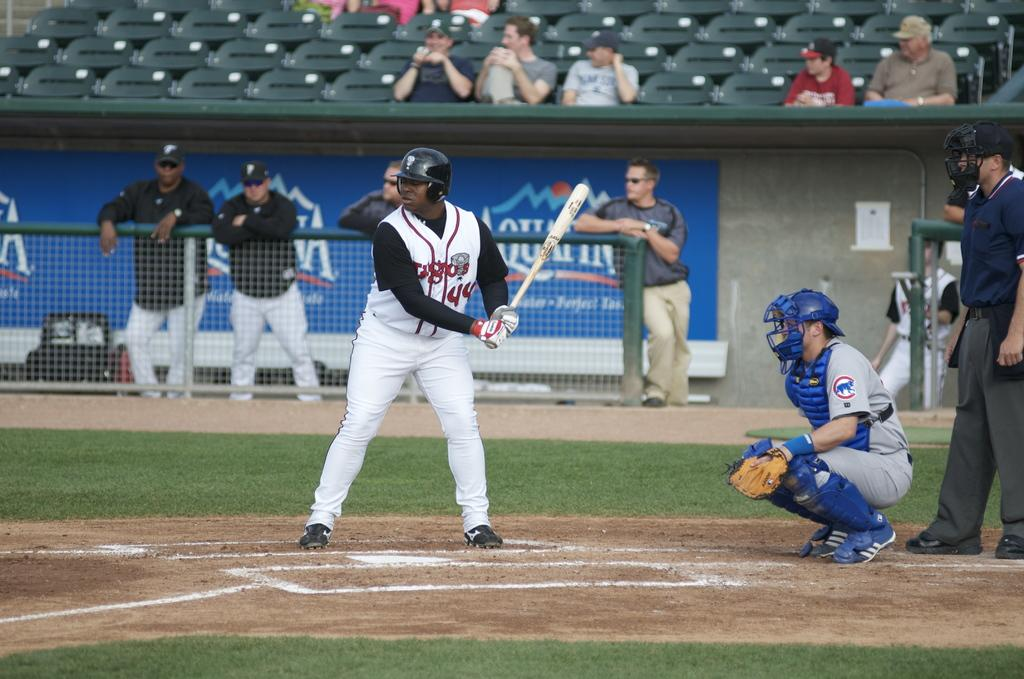<image>
Summarize the visual content of the image. A batter is in position in front of a banner for Aquafina water. 